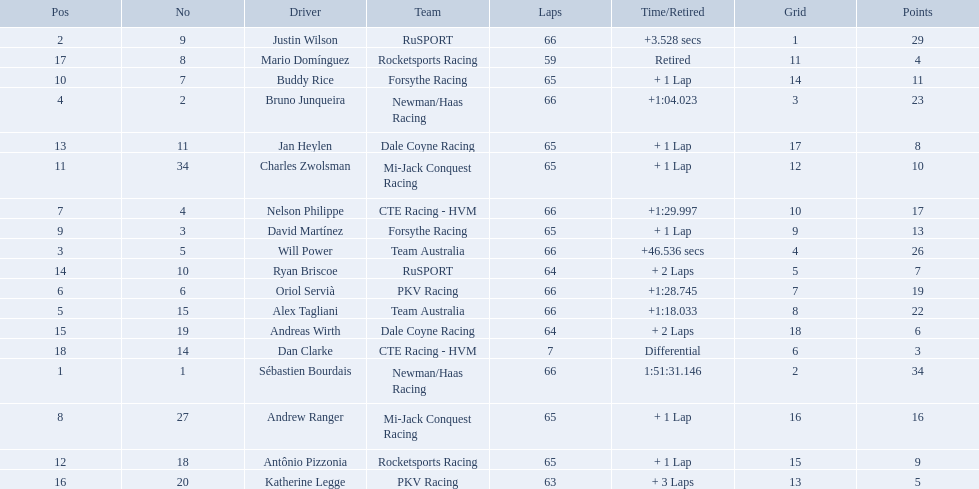What are the names of the drivers who were in position 14 through position 18? Ryan Briscoe, Andreas Wirth, Katherine Legge, Mario Domínguez, Dan Clarke. Of these , which ones didn't finish due to retired or differential? Mario Domínguez, Dan Clarke. Which one of the previous drivers retired? Mario Domínguez. Which of the drivers in question 2 had a differential? Dan Clarke. 